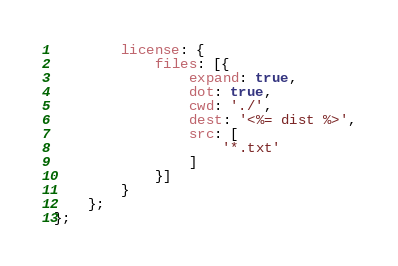<code> <loc_0><loc_0><loc_500><loc_500><_JavaScript_>        license: {
            files: [{
                expand: true,
                dot: true,
                cwd: './',
                dest: '<%= dist %>',
                src: [
                    '*.txt'
                ]
            }]
        }
    };
};
</code> 